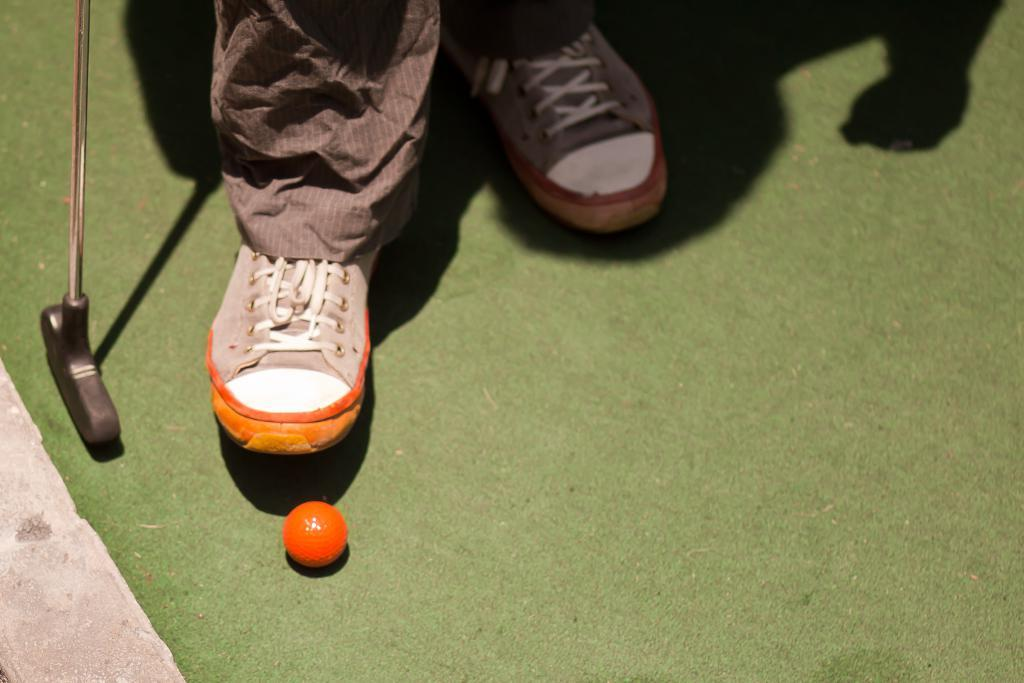What body part is visible in the image? There are person's legs in the image. What object is located beside the legs? There is a stick beside the legs. What object can be seen in the image besides the legs and stick? There is a ball in the image. What can be observed about the person's presence in the image? There is a shadow of a person in the image. What is the color of the surface where the shadow is cast? The shadow is on a green surface. What type of cake is being cut by the person in the image? There is no cake present in the image; it features a person's legs, a stick, a ball, and a shadow. 